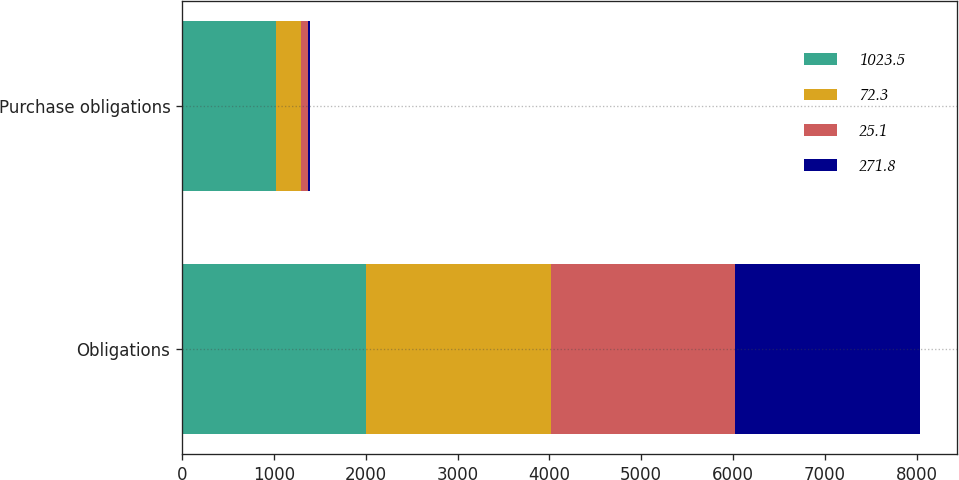Convert chart. <chart><loc_0><loc_0><loc_500><loc_500><stacked_bar_chart><ecel><fcel>Obligations<fcel>Purchase obligations<nl><fcel>1023.5<fcel>2007<fcel>1023.5<nl><fcel>72.3<fcel>2008<fcel>271.8<nl><fcel>25.1<fcel>2009<fcel>72.3<nl><fcel>271.8<fcel>2010<fcel>25.1<nl></chart> 